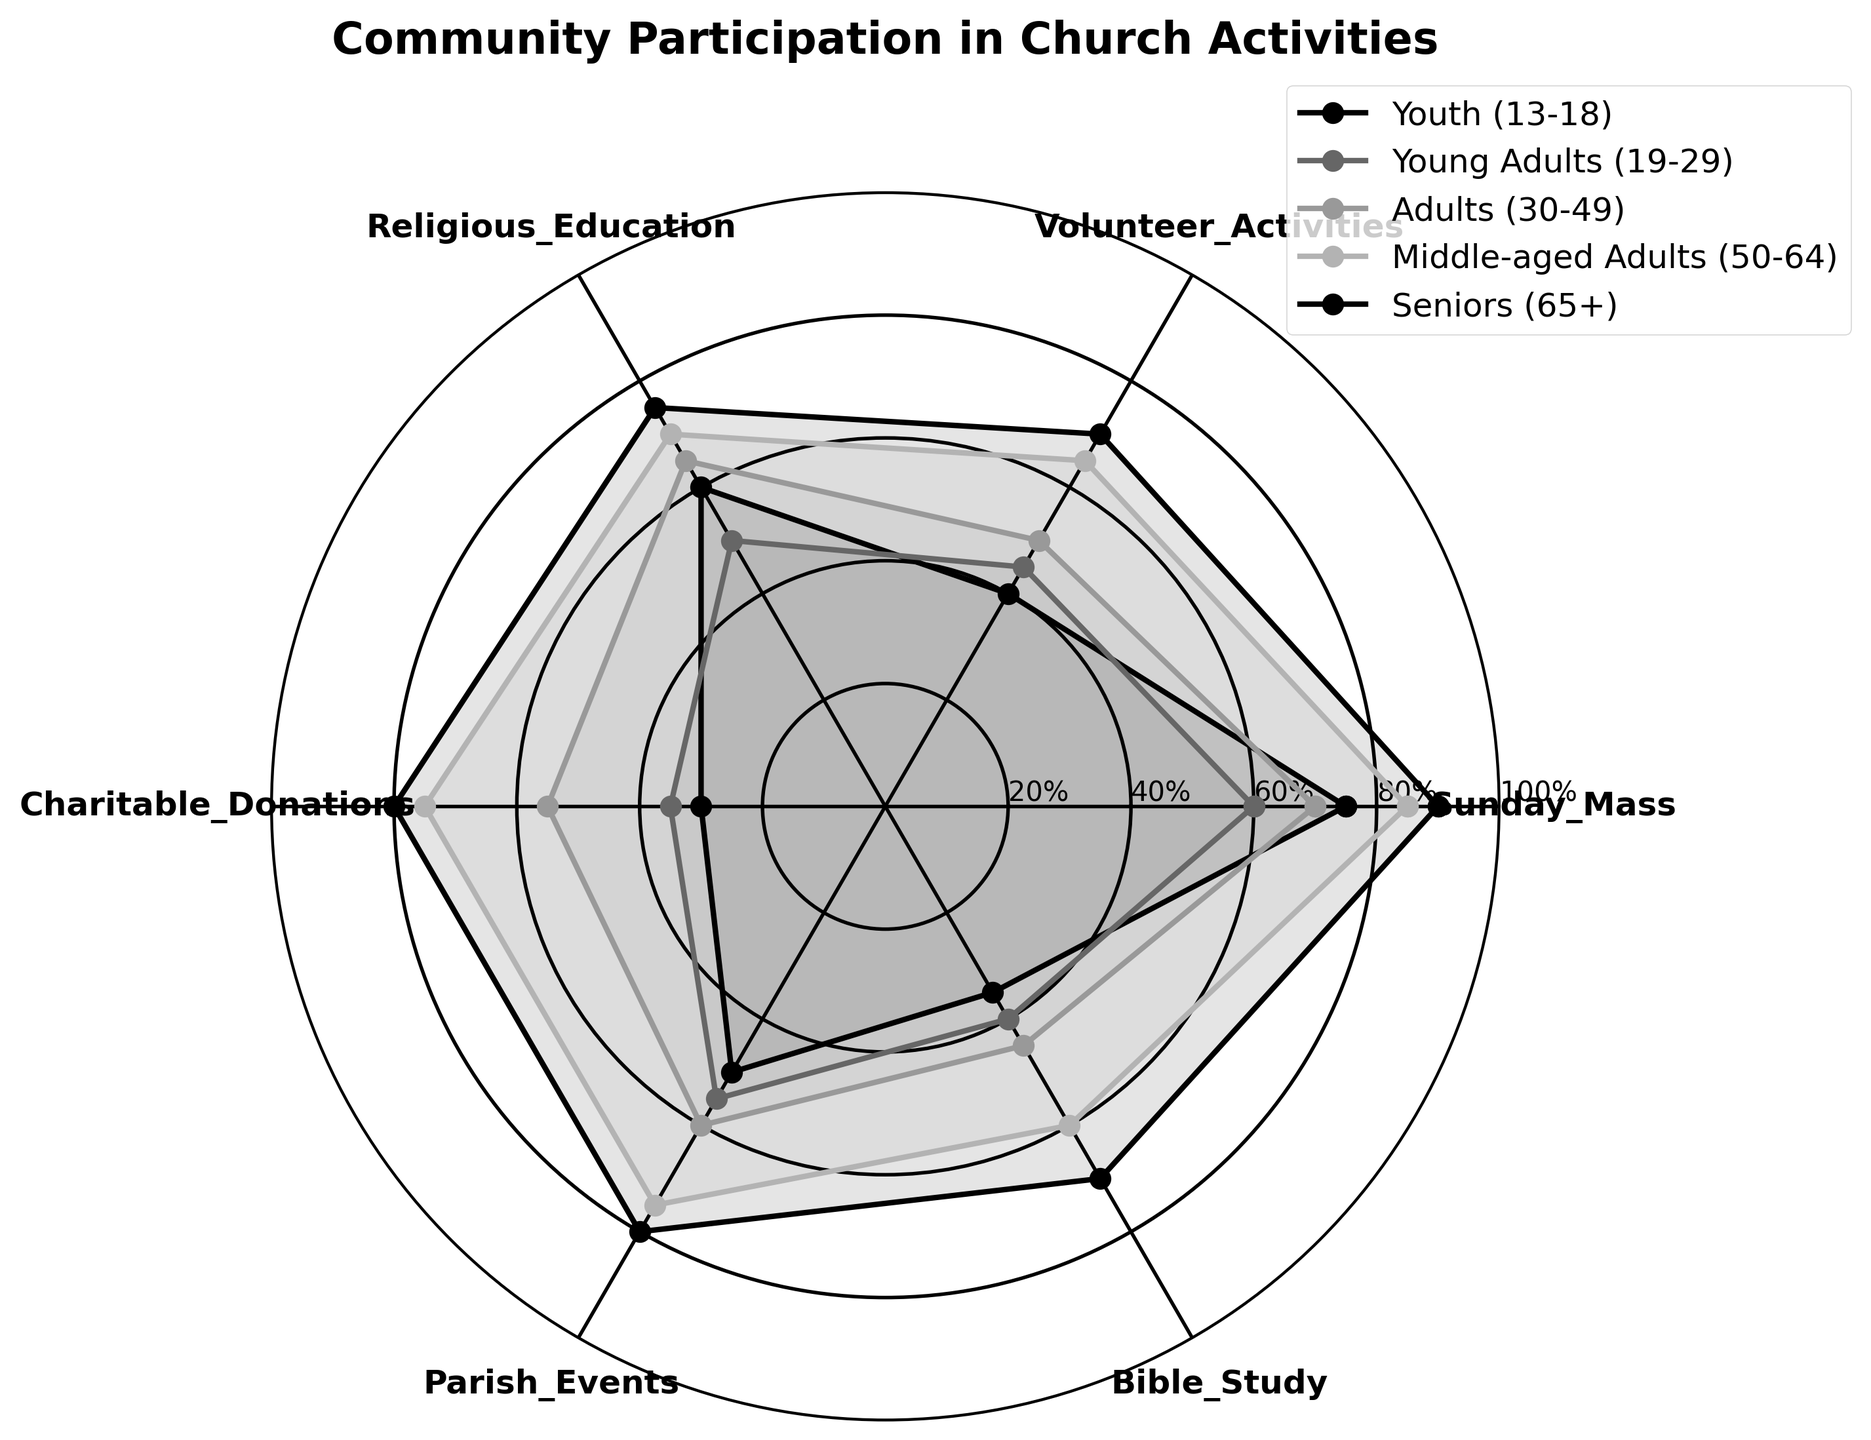What is the title of the radar chart? The title is located prominently at the top of the figure and reads "Community Participation in Church Activities".
Answer: Community Participation in Church Activities What are the categories of activities shown in the radar chart? The text labels positioned around the radar chart indicate the categories, which are Sunday Mass, Volunteer Activities, Religious Education, Charitable Donations, Parish Events, and Bible Study.
Answer: Sunday Mass, Volunteer Activities, Religious Education, Charitable Donations, Parish Events, Bible Study Which age group has the highest participation in Charitable Donations? By examining the outermost point on the axis corresponding to Charitable Donations, we find that the Seniors (65+) group reaches the farthest, indicating the highest value.
Answer: Seniors (65+) What's the average participation rate in Bible Study for all age groups? We calculate the average by summing the Bible Study values (35 + 40 + 45 + 60 + 70 = 250) and dividing by the number of age groups (5). The average is 250 / 5 = 50.
Answer: 50 Which two age groups have the smallest difference in participation in Sunday Mass and what is that difference? By comparing Sunday Mass participation rates (75 for Youth, 60 for Young Adults, 70 for Adults, 85 for Middle-aged Adults, and 90 for Seniors), the smallest difference is between Adults (70) and Young Adults (60). The difference is 70 - 60 = 10.
Answer: Adults (30-49) and Young Adults (19-29); 10 How does the participation in Parish Events compare among different age groups? We observe the points on the Parish Events axis: Youth (50), Young Adults (55), Adults (60), Middle-aged Adults (75), and Seniors (80). It consistently increases with age, with the lowest in the Youth and highest in the Seniors.
Answer: Increases with age, lowest in Youth, and highest in Seniors In which activity and age group do we observe the minimum participation rate? By examining all axes, the minimum participation rate is at Charitable Donations for the Youth (13-18), which is 30.
Answer: Charitable Donations; Youth (13-18) Calculate the median value of participation in Religious Education across all age groups. To find the median, we list the Religious Education values (60, 50, 65, 70, 75). Arranging these in ascending order: 50, 60, 65, 70, 75. The median, being the middle value in this ordered list, is 65.
Answer: 65 Which activity has the most similar participation rate across all age groups? Observing the radials, Bible Study appears the most evenly spread across all age groups with values: 35, 40, 45, 60, and 70, showing minimal variations compared to other categories.
Answer: Bible Study 